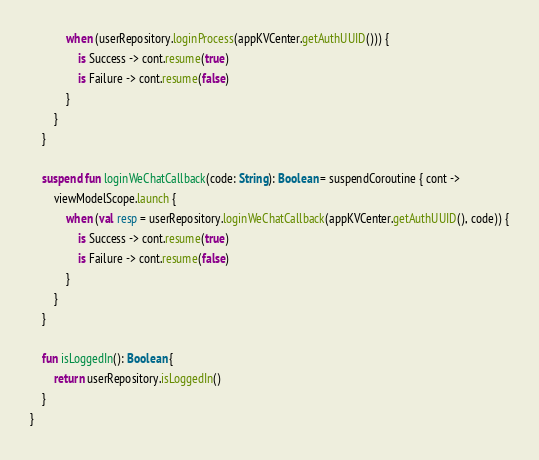Convert code to text. <code><loc_0><loc_0><loc_500><loc_500><_Kotlin_>            when (userRepository.loginProcess(appKVCenter.getAuthUUID())) {
                is Success -> cont.resume(true)
                is Failure -> cont.resume(false)
            }
        }
    }

    suspend fun loginWeChatCallback(code: String): Boolean = suspendCoroutine { cont ->
        viewModelScope.launch {
            when (val resp = userRepository.loginWeChatCallback(appKVCenter.getAuthUUID(), code)) {
                is Success -> cont.resume(true)
                is Failure -> cont.resume(false)
            }
        }
    }

    fun isLoggedIn(): Boolean {
        return userRepository.isLoggedIn()
    }
}</code> 